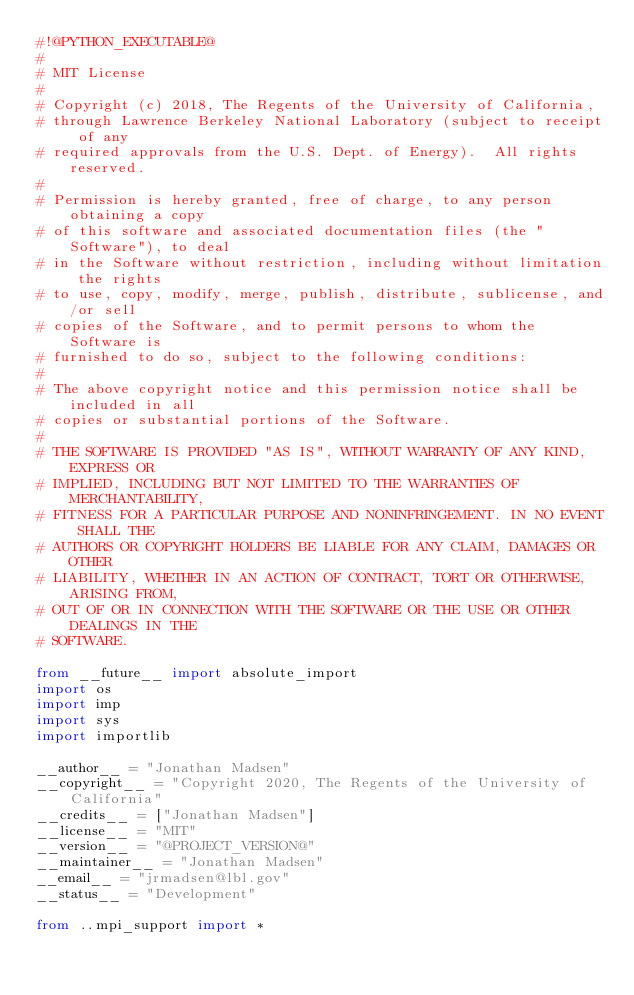<code> <loc_0><loc_0><loc_500><loc_500><_Python_>#!@PYTHON_EXECUTABLE@
#
# MIT License
#
# Copyright (c) 2018, The Regents of the University of California,
# through Lawrence Berkeley National Laboratory (subject to receipt of any
# required approvals from the U.S. Dept. of Energy).  All rights reserved.
#
# Permission is hereby granted, free of charge, to any person obtaining a copy
# of this software and associated documentation files (the "Software"), to deal
# in the Software without restriction, including without limitation the rights
# to use, copy, modify, merge, publish, distribute, sublicense, and/or sell
# copies of the Software, and to permit persons to whom the Software is
# furnished to do so, subject to the following conditions:
#
# The above copyright notice and this permission notice shall be included in all
# copies or substantial portions of the Software.
#
# THE SOFTWARE IS PROVIDED "AS IS", WITHOUT WARRANTY OF ANY KIND, EXPRESS OR
# IMPLIED, INCLUDING BUT NOT LIMITED TO THE WARRANTIES OF MERCHANTABILITY,
# FITNESS FOR A PARTICULAR PURPOSE AND NONINFRINGEMENT. IN NO EVENT SHALL THE
# AUTHORS OR COPYRIGHT HOLDERS BE LIABLE FOR ANY CLAIM, DAMAGES OR OTHER
# LIABILITY, WHETHER IN AN ACTION OF CONTRACT, TORT OR OTHERWISE, ARISING FROM,
# OUT OF OR IN CONNECTION WITH THE SOFTWARE OR THE USE OR OTHER DEALINGS IN THE
# SOFTWARE.

from __future__ import absolute_import
import os
import imp
import sys
import importlib

__author__ = "Jonathan Madsen"
__copyright__ = "Copyright 2020, The Regents of the University of California"
__credits__ = ["Jonathan Madsen"]
__license__ = "MIT"
__version__ = "@PROJECT_VERSION@"
__maintainer__ = "Jonathan Madsen"
__email__ = "jrmadsen@lbl.gov"
__status__ = "Development"

from ..mpi_support import *
</code> 